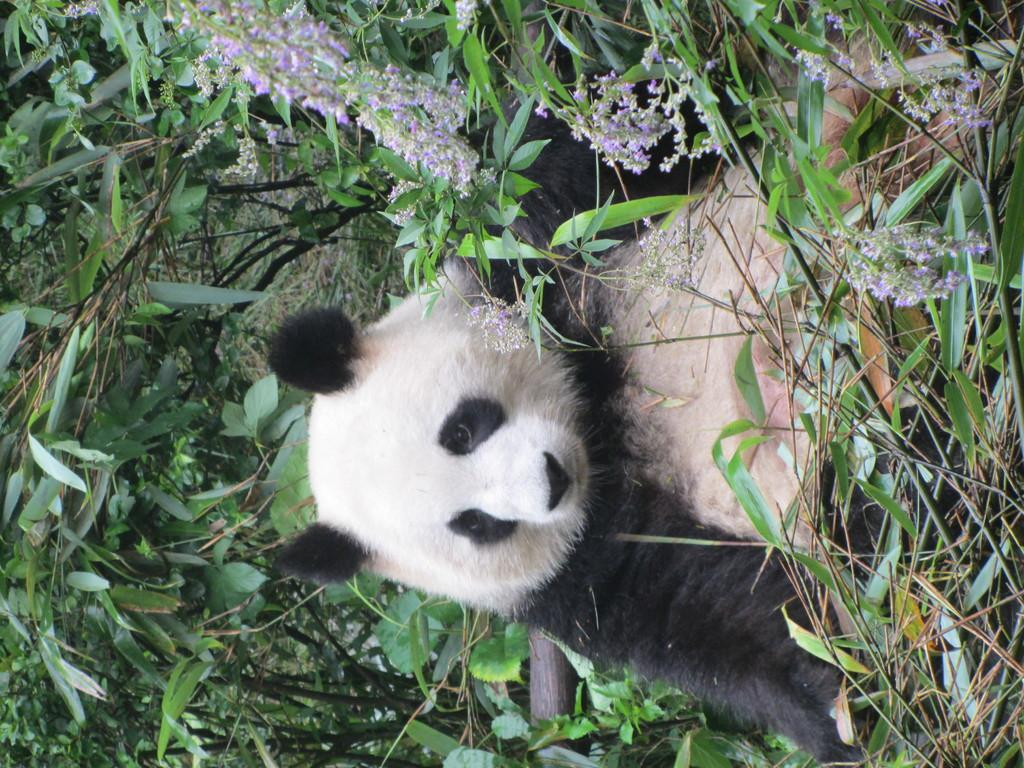What animal is present in the image? There is a panda in the image. What colors can be seen on the panda? The panda is black and white in color. Where is the panda located in the image? The panda is on the ground. What type of vegetation is visible in the image? There are trees and flowers in the image. What colors are the flowers? The flowers are violet and white in color. Can you tell me how many clouds are present in the image? There are no clouds visible in the image; it features a panda on the ground with trees and flowers. Is there a cushion being used by the panda in the image? There is no cushion present in the image; the panda is on the ground. 